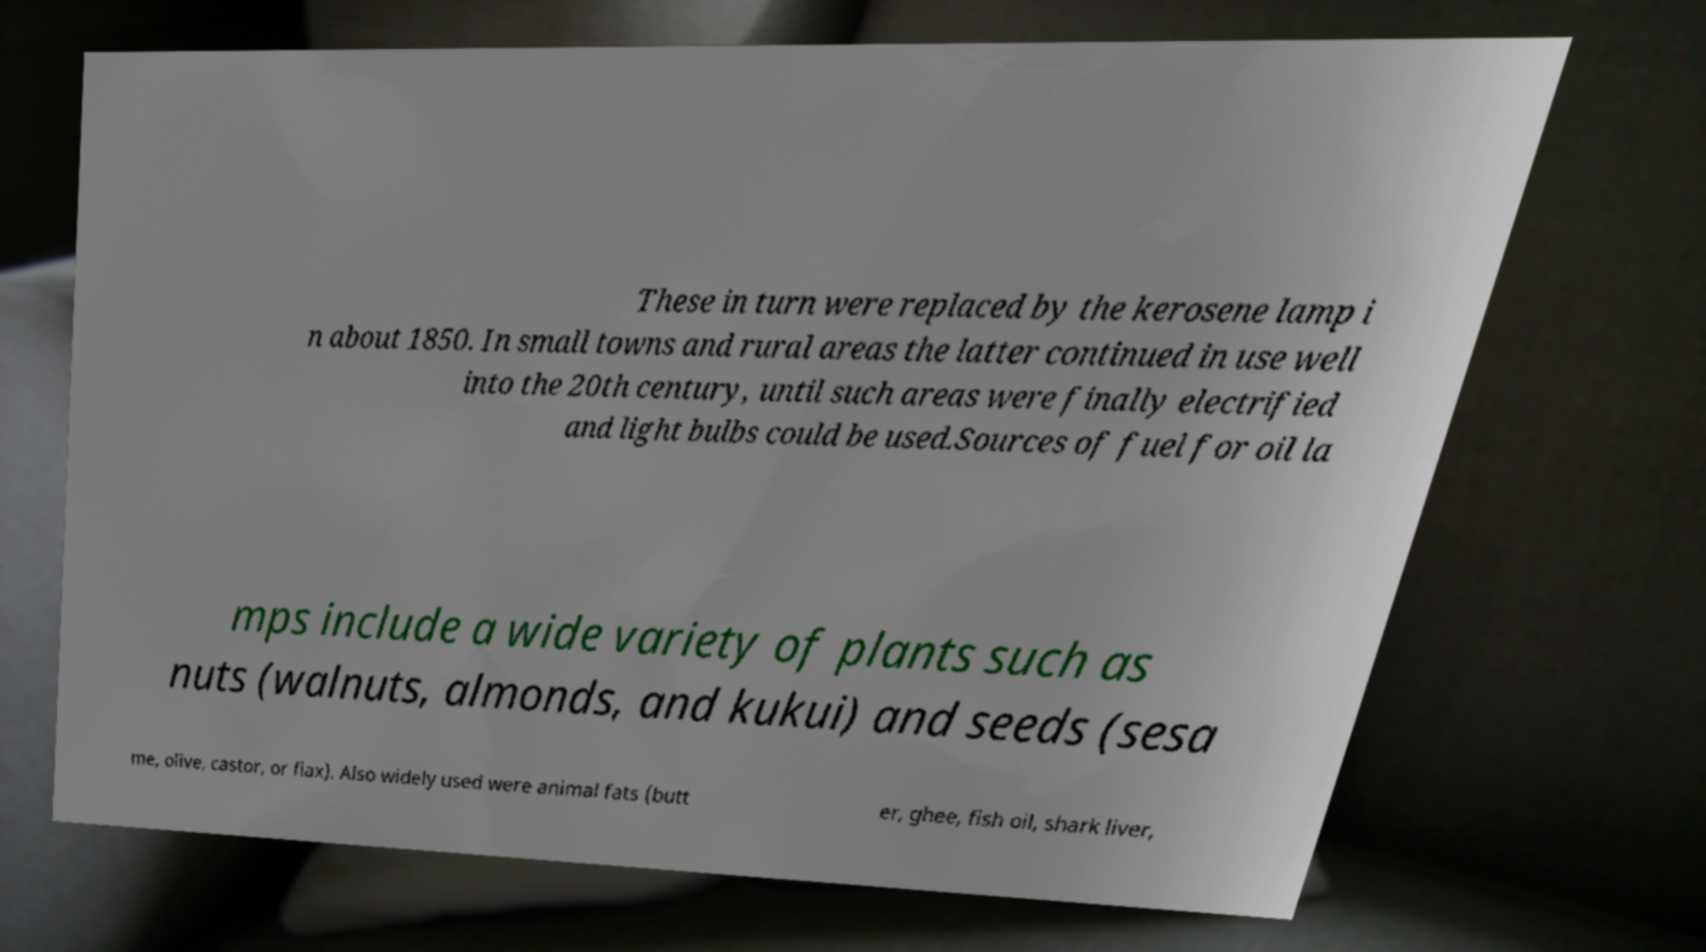Can you accurately transcribe the text from the provided image for me? These in turn were replaced by the kerosene lamp i n about 1850. In small towns and rural areas the latter continued in use well into the 20th century, until such areas were finally electrified and light bulbs could be used.Sources of fuel for oil la mps include a wide variety of plants such as nuts (walnuts, almonds, and kukui) and seeds (sesa me, olive, castor, or flax). Also widely used were animal fats (butt er, ghee, fish oil, shark liver, 